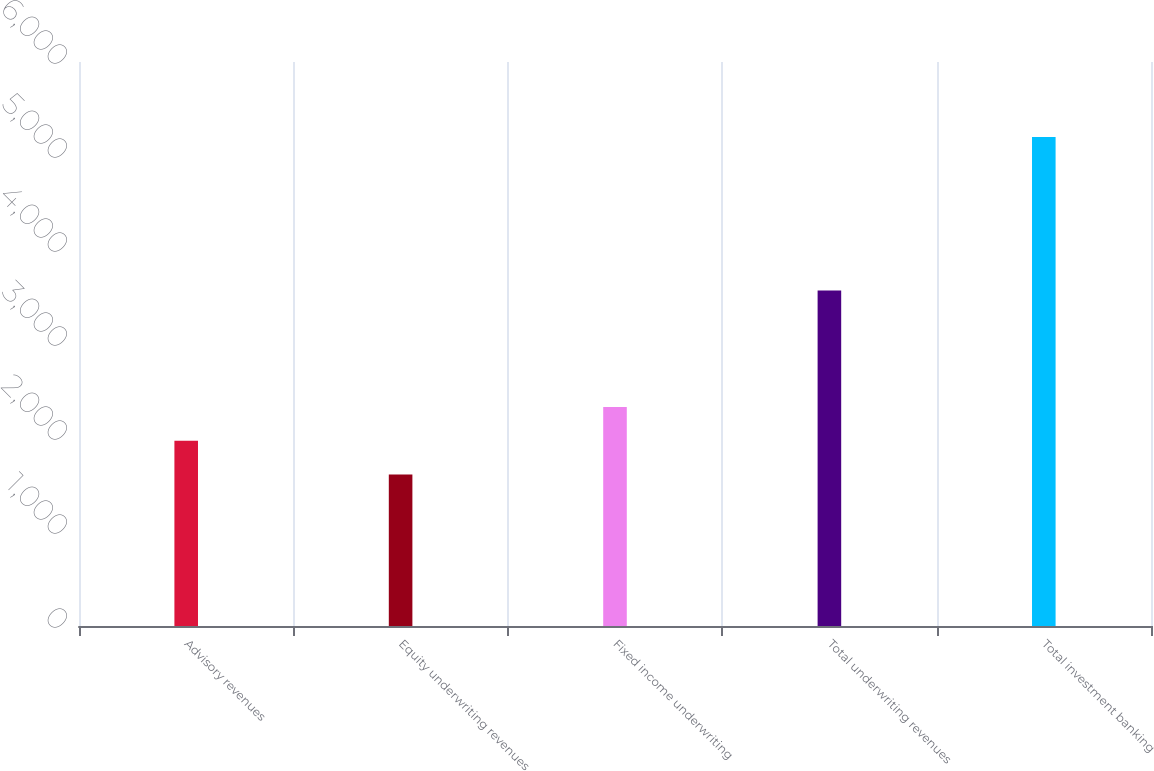Convert chart. <chart><loc_0><loc_0><loc_500><loc_500><bar_chart><fcel>Advisory revenues<fcel>Equity underwriting revenues<fcel>Fixed income underwriting<fcel>Total underwriting revenues<fcel>Total investment banking<nl><fcel>1972<fcel>1613<fcel>2331<fcel>3569<fcel>5203<nl></chart> 